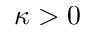<formula> <loc_0><loc_0><loc_500><loc_500>\kappa > 0</formula> 